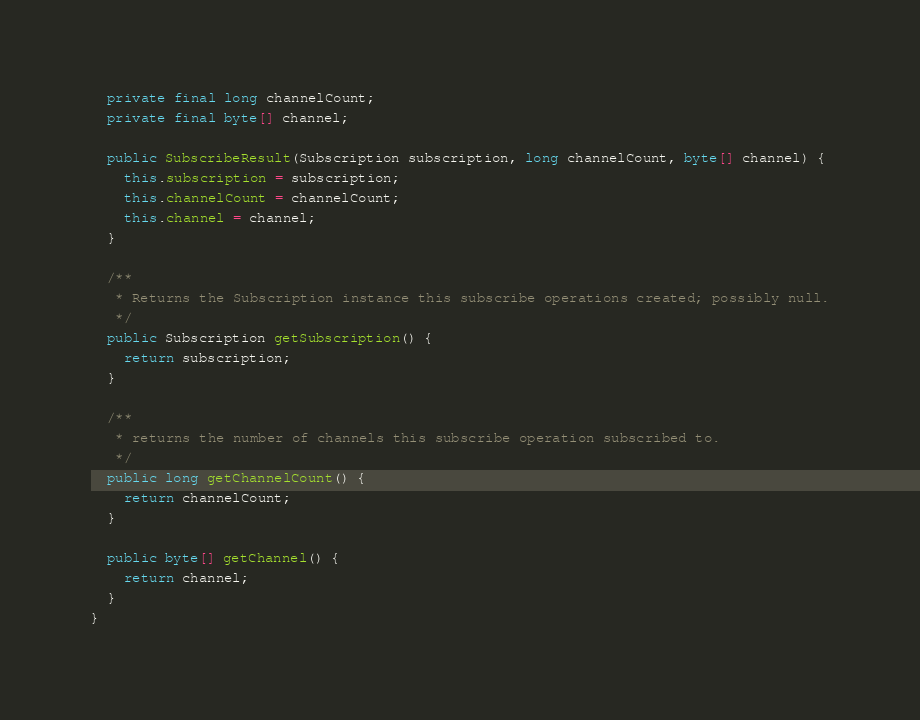<code> <loc_0><loc_0><loc_500><loc_500><_Java_>  private final long channelCount;
  private final byte[] channel;

  public SubscribeResult(Subscription subscription, long channelCount, byte[] channel) {
    this.subscription = subscription;
    this.channelCount = channelCount;
    this.channel = channel;
  }

  /**
   * Returns the Subscription instance this subscribe operations created; possibly null.
   */
  public Subscription getSubscription() {
    return subscription;
  }

  /**
   * returns the number of channels this subscribe operation subscribed to.
   */
  public long getChannelCount() {
    return channelCount;
  }

  public byte[] getChannel() {
    return channel;
  }
}
</code> 